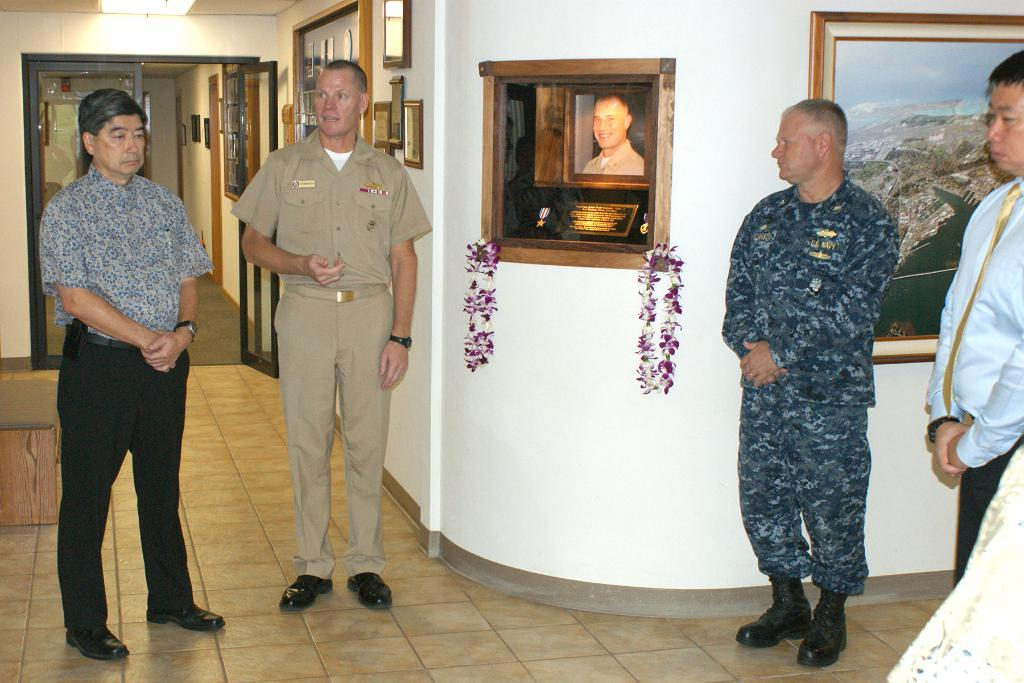Where was the image taken? The image was taken inside a room. What can be seen in the middle of the room? There are photo frames in the middle of the room. How many people are in the room? There are 4 persons standing in the room. What is located on the left side of the room? There is a door on the left side of the room. What is the source of light in the room? There is light at the top of the room. Who is the owner of the finger seen in the image? There is no finger visible in the image. 